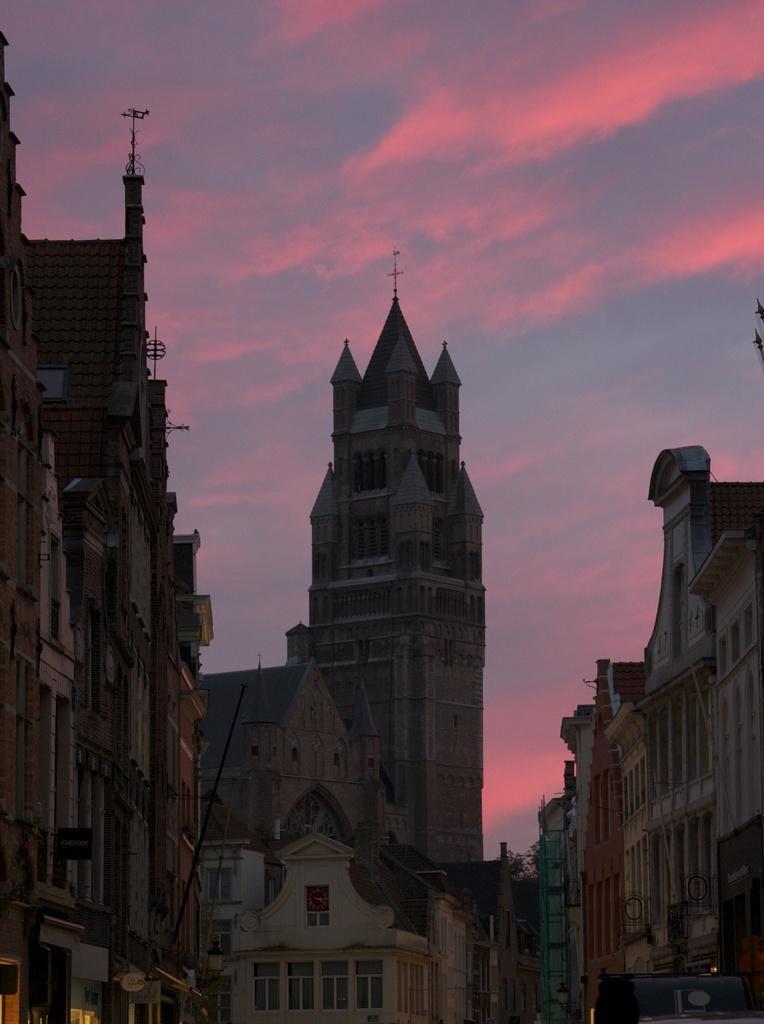What type of structures can be seen in the image? There are buildings in the image. What feature can be observed on the buildings? There are metal rods on the buildings. What type of vegetation is visible in the background of the image? There are trees in the background of the image. What part of the natural environment is visible in the image? The sky is visible in the background of the image. What type of plants can be seen growing on the metal rods in the image? There are no plants growing on the metal rods in the image. What color is the hair of the person standing next to the building in the image? There is no person with hair visible in the image; it only features buildings, metal rods, trees, and the sky. 